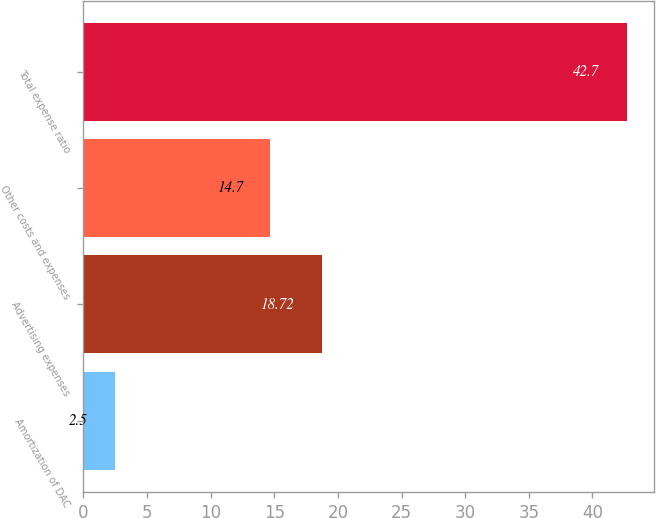<chart> <loc_0><loc_0><loc_500><loc_500><bar_chart><fcel>Amortization of DAC<fcel>Advertising expenses<fcel>Other costs and expenses<fcel>Total expense ratio<nl><fcel>2.5<fcel>18.72<fcel>14.7<fcel>42.7<nl></chart> 